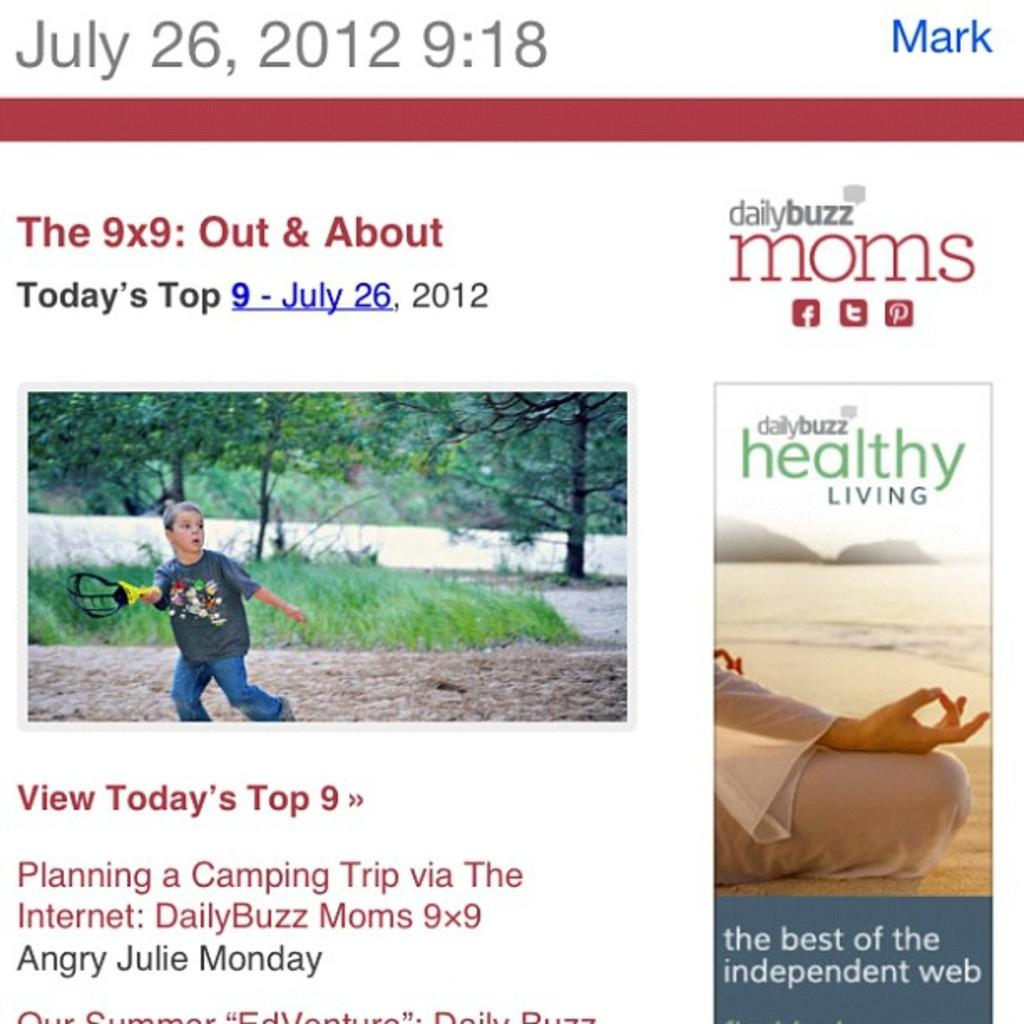What is the main object in the image? There is a post in the image. What can be found on the post? There are texts and pictures on the post. What type of fish can be seen swimming around the post in the image? There are no fish present in the image; it only features a post with texts and pictures. What is the zinc content of the post in the image? The zinc content of the post cannot be determined from the image, as it does not provide information about the materials used in the post's construction. 